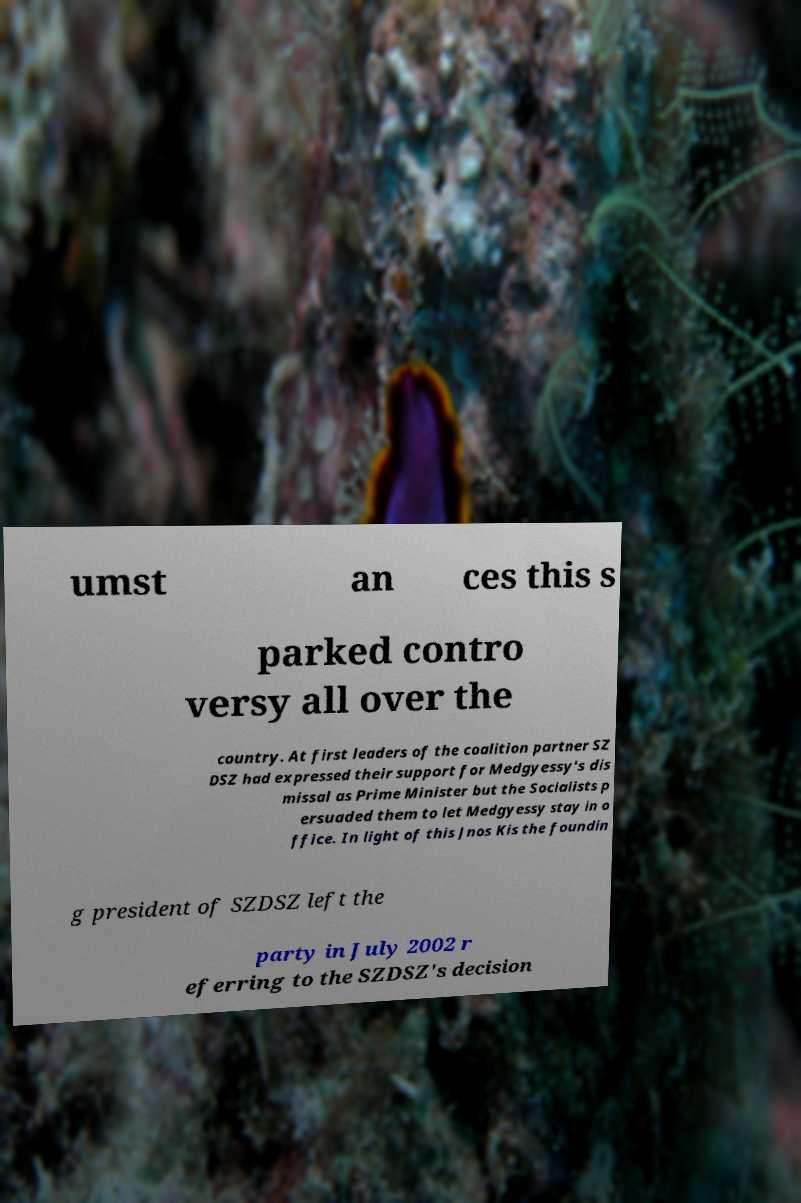Please identify and transcribe the text found in this image. umst an ces this s parked contro versy all over the country. At first leaders of the coalition partner SZ DSZ had expressed their support for Medgyessy's dis missal as Prime Minister but the Socialists p ersuaded them to let Medgyessy stay in o ffice. In light of this Jnos Kis the foundin g president of SZDSZ left the party in July 2002 r eferring to the SZDSZ's decision 